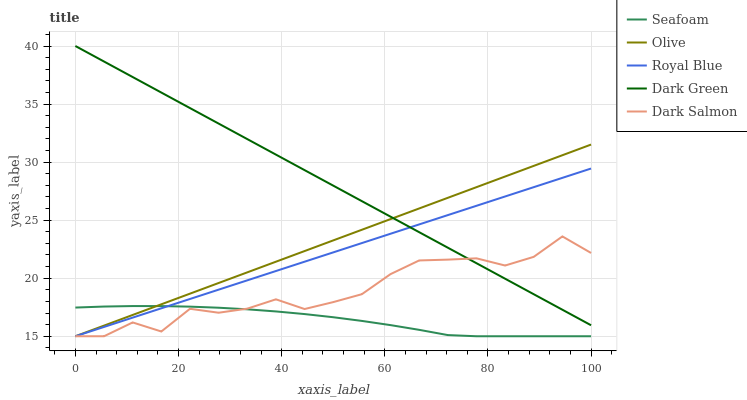Does Royal Blue have the minimum area under the curve?
Answer yes or no. No. Does Royal Blue have the maximum area under the curve?
Answer yes or no. No. Is Royal Blue the smoothest?
Answer yes or no. No. Is Royal Blue the roughest?
Answer yes or no. No. Does Dark Green have the lowest value?
Answer yes or no. No. Does Royal Blue have the highest value?
Answer yes or no. No. Is Seafoam less than Dark Green?
Answer yes or no. Yes. Is Dark Green greater than Seafoam?
Answer yes or no. Yes. Does Seafoam intersect Dark Green?
Answer yes or no. No. 